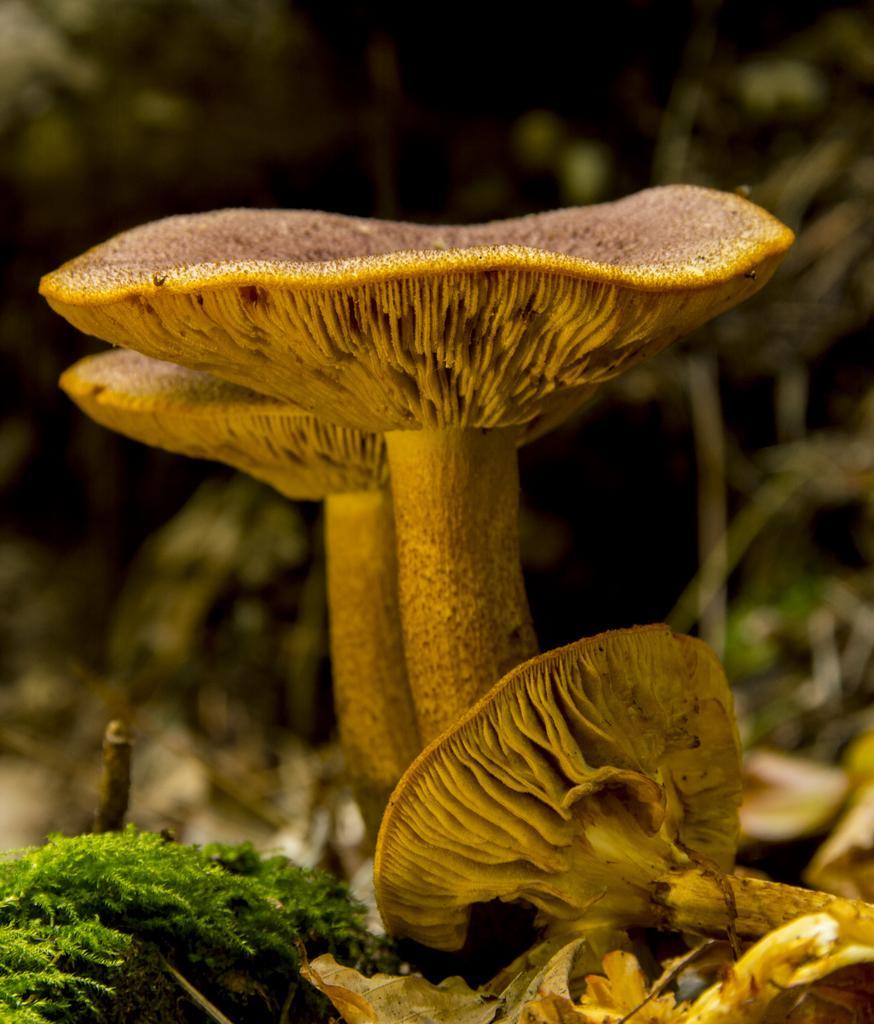Please provide a concise description of this image. In this pictures we can see mushrooms and plants. In the background of the image it is blurry. 